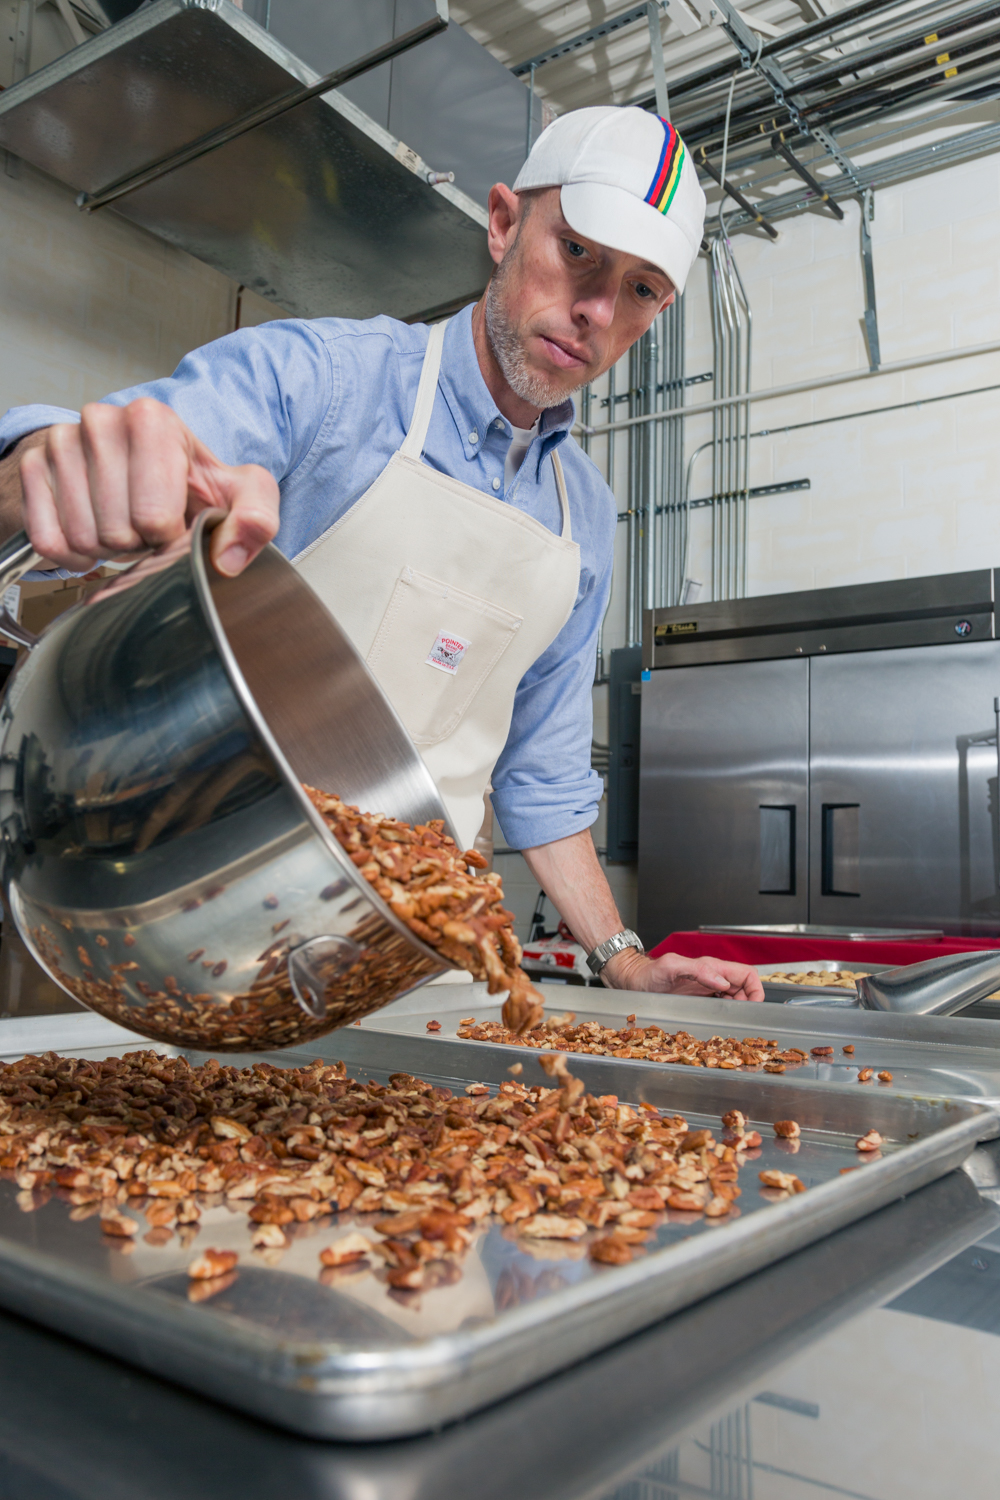What is the man doing in the kitchen, and what can you infer from his activity about the type of food being prepared? The man is pouring a large quantity of nuts from a stainless steel pot onto trays, which suggests that these nuts might be getting prepared for roasting or further processing. This activity points toward the preparation of snacks, confectionery products, or ingredients for baked goods. Given the professional setting and the scale of production, it’s likely that the establishment might be involved in producing gourmet nuts or utilizing them extensively in their recipes. What can you tell about the level of professionalism and hygiene standards maintained in this kitchen? The level of professionalism in this kitchen is high, as evidenced by the man's attire which includes a clean apron and a cap. These items are typically worn to maintain hygiene and prevent contamination. Furthermore, the kitchen is equipped with commercial-grade appliances, which are indicative of a professional setting that likely adheres to strict food safety regulations. The stainless steel surfaces and organized environment further suggest that cleanliness and efficiency are prioritized in this workspace. 